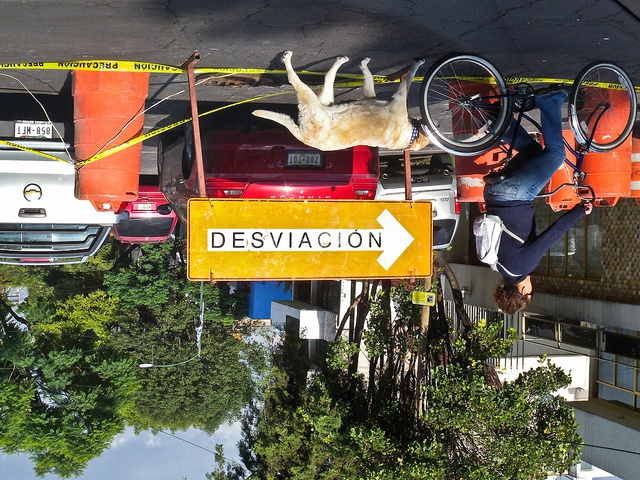Describe the objects in this image and their specific colors. I can see bicycle in gray, black, maroon, and salmon tones, car in gray, black, maroon, and red tones, car in gray, white, black, and darkgray tones, people in gray, black, navy, and darkblue tones, and dog in gray, beige, and tan tones in this image. 